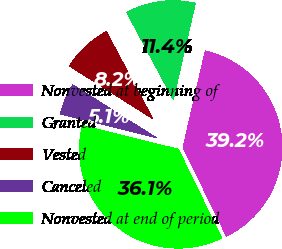Convert chart to OTSL. <chart><loc_0><loc_0><loc_500><loc_500><pie_chart><fcel>Nonvested at beginning of<fcel>Granted<fcel>Vested<fcel>Canceled<fcel>Nonvested at end of period<nl><fcel>39.18%<fcel>11.4%<fcel>8.22%<fcel>5.12%<fcel>36.08%<nl></chart> 